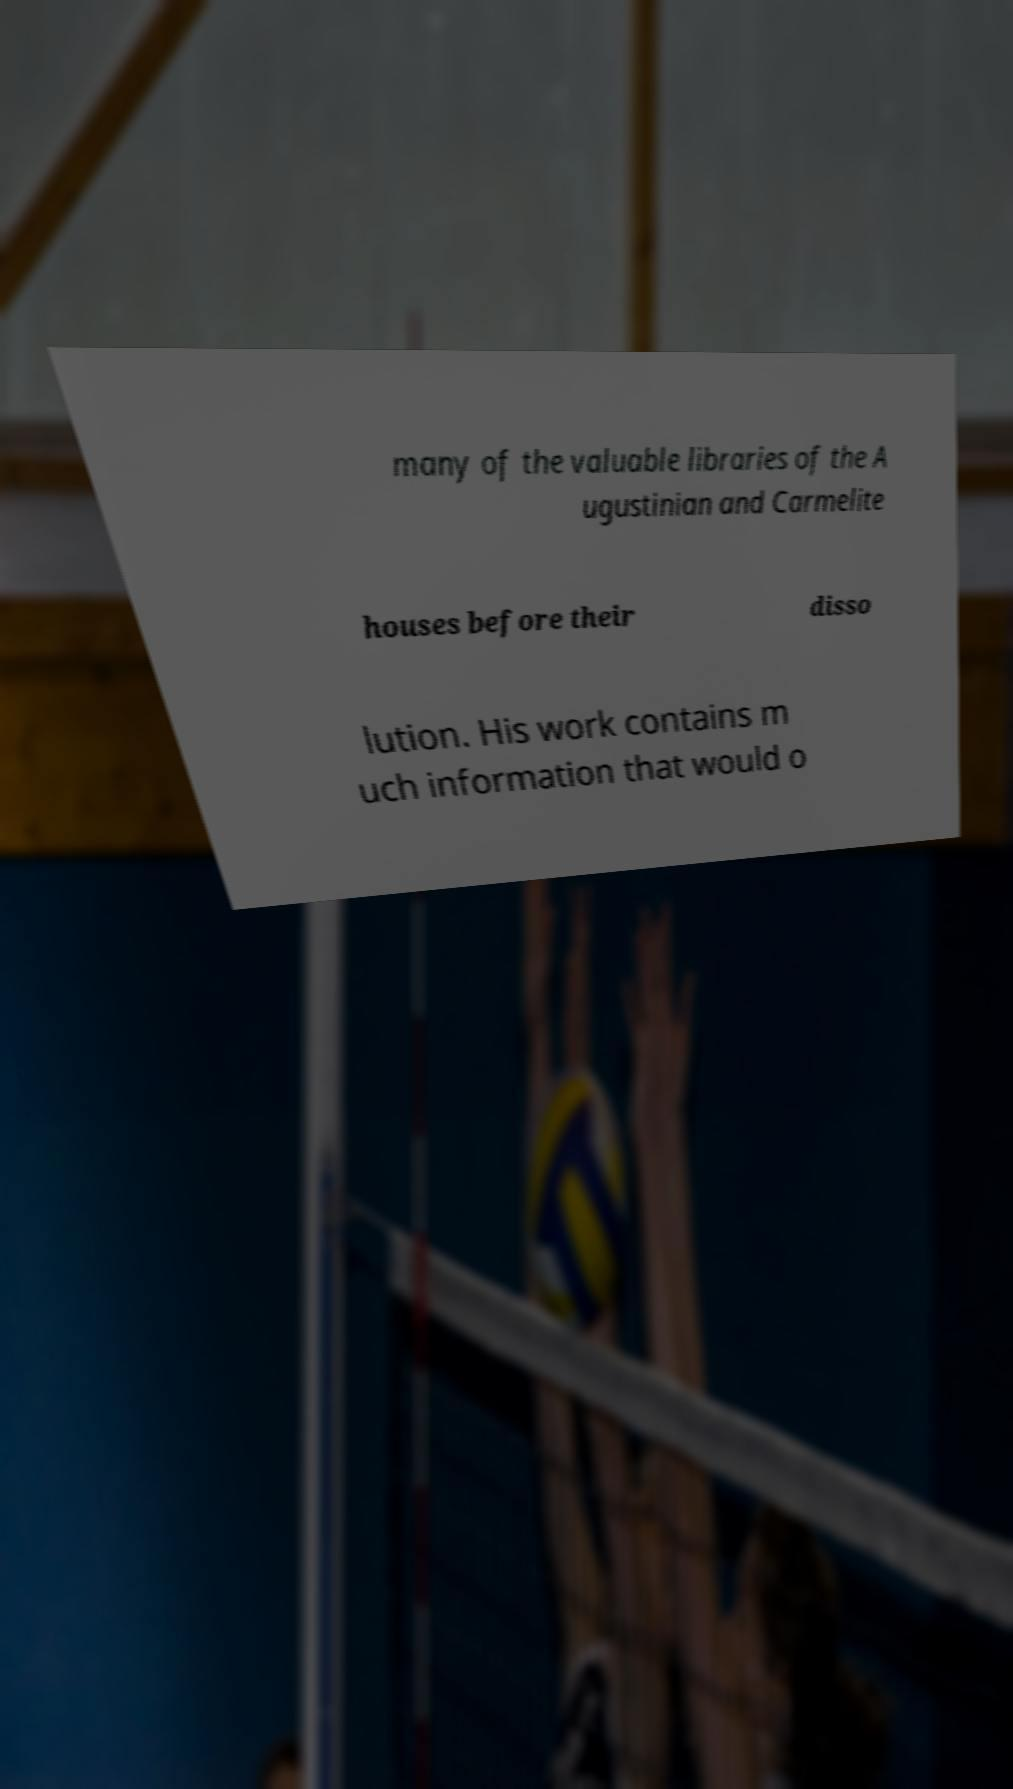Can you accurately transcribe the text from the provided image for me? many of the valuable libraries of the A ugustinian and Carmelite houses before their disso lution. His work contains m uch information that would o 